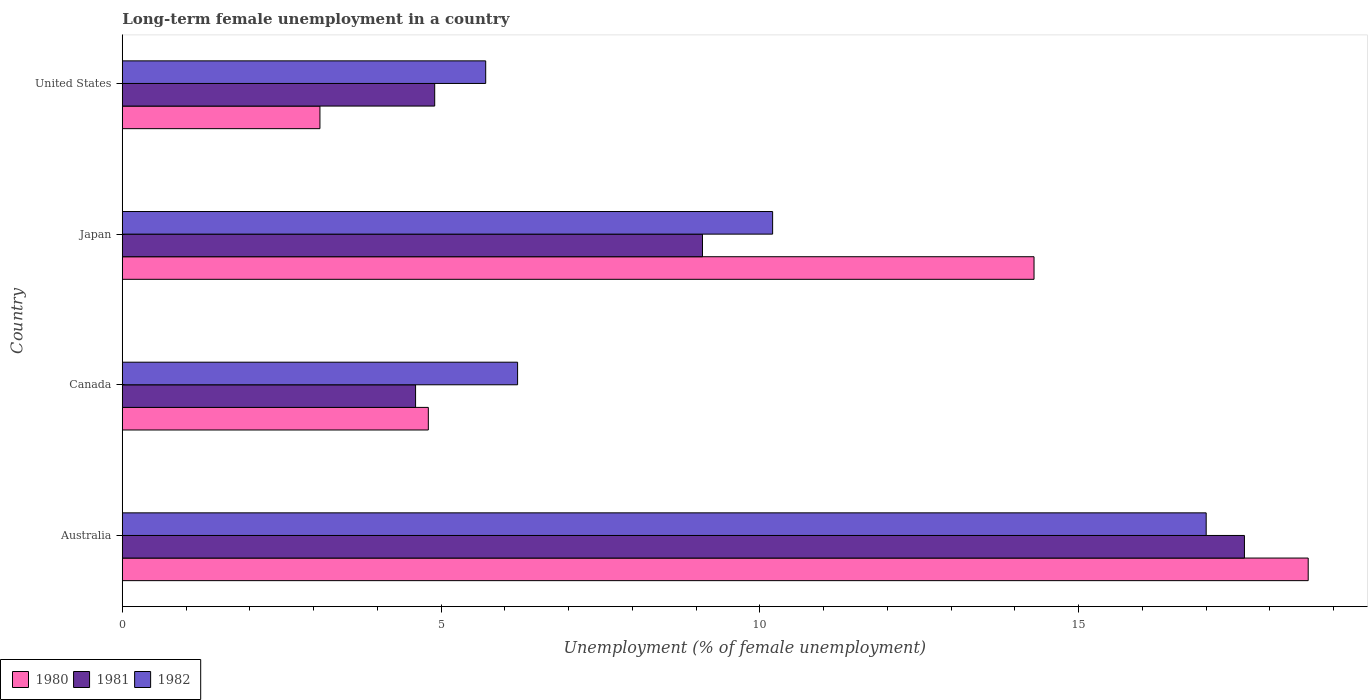How many different coloured bars are there?
Your response must be concise. 3. How many groups of bars are there?
Your answer should be compact. 4. Are the number of bars per tick equal to the number of legend labels?
Offer a terse response. Yes. How many bars are there on the 2nd tick from the top?
Make the answer very short. 3. In how many cases, is the number of bars for a given country not equal to the number of legend labels?
Offer a very short reply. 0. What is the percentage of long-term unemployed female population in 1980 in Japan?
Your answer should be very brief. 14.3. Across all countries, what is the maximum percentage of long-term unemployed female population in 1980?
Offer a terse response. 18.6. Across all countries, what is the minimum percentage of long-term unemployed female population in 1982?
Make the answer very short. 5.7. In which country was the percentage of long-term unemployed female population in 1980 minimum?
Make the answer very short. United States. What is the total percentage of long-term unemployed female population in 1981 in the graph?
Offer a very short reply. 36.2. What is the difference between the percentage of long-term unemployed female population in 1980 in Canada and that in Japan?
Your response must be concise. -9.5. What is the difference between the percentage of long-term unemployed female population in 1980 in Japan and the percentage of long-term unemployed female population in 1981 in Canada?
Provide a short and direct response. 9.7. What is the average percentage of long-term unemployed female population in 1981 per country?
Make the answer very short. 9.05. What is the difference between the percentage of long-term unemployed female population in 1982 and percentage of long-term unemployed female population in 1980 in Japan?
Give a very brief answer. -4.1. In how many countries, is the percentage of long-term unemployed female population in 1981 greater than 4 %?
Your answer should be compact. 4. What is the ratio of the percentage of long-term unemployed female population in 1982 in Australia to that in United States?
Your answer should be very brief. 2.98. Is the difference between the percentage of long-term unemployed female population in 1982 in Australia and United States greater than the difference between the percentage of long-term unemployed female population in 1980 in Australia and United States?
Offer a very short reply. No. What is the difference between the highest and the second highest percentage of long-term unemployed female population in 1982?
Give a very brief answer. 6.8. What is the difference between the highest and the lowest percentage of long-term unemployed female population in 1980?
Provide a short and direct response. 15.5. In how many countries, is the percentage of long-term unemployed female population in 1980 greater than the average percentage of long-term unemployed female population in 1980 taken over all countries?
Your answer should be very brief. 2. Is the sum of the percentage of long-term unemployed female population in 1980 in Australia and United States greater than the maximum percentage of long-term unemployed female population in 1982 across all countries?
Your response must be concise. Yes. What does the 1st bar from the bottom in Japan represents?
Your answer should be compact. 1980. Are all the bars in the graph horizontal?
Offer a very short reply. Yes. What is the difference between two consecutive major ticks on the X-axis?
Keep it short and to the point. 5. Are the values on the major ticks of X-axis written in scientific E-notation?
Your response must be concise. No. Where does the legend appear in the graph?
Keep it short and to the point. Bottom left. How many legend labels are there?
Offer a terse response. 3. What is the title of the graph?
Offer a terse response. Long-term female unemployment in a country. Does "2004" appear as one of the legend labels in the graph?
Offer a terse response. No. What is the label or title of the X-axis?
Give a very brief answer. Unemployment (% of female unemployment). What is the label or title of the Y-axis?
Make the answer very short. Country. What is the Unemployment (% of female unemployment) of 1980 in Australia?
Your answer should be compact. 18.6. What is the Unemployment (% of female unemployment) of 1981 in Australia?
Your answer should be very brief. 17.6. What is the Unemployment (% of female unemployment) in 1980 in Canada?
Keep it short and to the point. 4.8. What is the Unemployment (% of female unemployment) in 1981 in Canada?
Give a very brief answer. 4.6. What is the Unemployment (% of female unemployment) in 1982 in Canada?
Provide a short and direct response. 6.2. What is the Unemployment (% of female unemployment) in 1980 in Japan?
Give a very brief answer. 14.3. What is the Unemployment (% of female unemployment) in 1981 in Japan?
Your answer should be very brief. 9.1. What is the Unemployment (% of female unemployment) of 1982 in Japan?
Your response must be concise. 10.2. What is the Unemployment (% of female unemployment) of 1980 in United States?
Provide a short and direct response. 3.1. What is the Unemployment (% of female unemployment) of 1981 in United States?
Keep it short and to the point. 4.9. What is the Unemployment (% of female unemployment) of 1982 in United States?
Make the answer very short. 5.7. Across all countries, what is the maximum Unemployment (% of female unemployment) of 1980?
Your response must be concise. 18.6. Across all countries, what is the maximum Unemployment (% of female unemployment) in 1981?
Provide a succinct answer. 17.6. Across all countries, what is the minimum Unemployment (% of female unemployment) of 1980?
Give a very brief answer. 3.1. Across all countries, what is the minimum Unemployment (% of female unemployment) of 1981?
Offer a terse response. 4.6. Across all countries, what is the minimum Unemployment (% of female unemployment) in 1982?
Provide a short and direct response. 5.7. What is the total Unemployment (% of female unemployment) in 1980 in the graph?
Offer a very short reply. 40.8. What is the total Unemployment (% of female unemployment) of 1981 in the graph?
Your answer should be very brief. 36.2. What is the total Unemployment (% of female unemployment) of 1982 in the graph?
Provide a succinct answer. 39.1. What is the difference between the Unemployment (% of female unemployment) of 1981 in Australia and that in Canada?
Keep it short and to the point. 13. What is the difference between the Unemployment (% of female unemployment) in 1982 in Australia and that in Canada?
Provide a short and direct response. 10.8. What is the difference between the Unemployment (% of female unemployment) of 1980 in Australia and that in Japan?
Your answer should be very brief. 4.3. What is the difference between the Unemployment (% of female unemployment) in 1981 in Australia and that in Japan?
Make the answer very short. 8.5. What is the difference between the Unemployment (% of female unemployment) of 1982 in Australia and that in Japan?
Your response must be concise. 6.8. What is the difference between the Unemployment (% of female unemployment) in 1980 in Australia and that in United States?
Make the answer very short. 15.5. What is the difference between the Unemployment (% of female unemployment) of 1980 in Canada and that in Japan?
Give a very brief answer. -9.5. What is the difference between the Unemployment (% of female unemployment) in 1982 in Canada and that in United States?
Offer a very short reply. 0.5. What is the difference between the Unemployment (% of female unemployment) of 1980 in Australia and the Unemployment (% of female unemployment) of 1981 in Canada?
Keep it short and to the point. 14. What is the difference between the Unemployment (% of female unemployment) of 1981 in Australia and the Unemployment (% of female unemployment) of 1982 in Canada?
Ensure brevity in your answer.  11.4. What is the difference between the Unemployment (% of female unemployment) of 1981 in Australia and the Unemployment (% of female unemployment) of 1982 in Japan?
Offer a terse response. 7.4. What is the difference between the Unemployment (% of female unemployment) in 1980 in Australia and the Unemployment (% of female unemployment) in 1981 in United States?
Provide a succinct answer. 13.7. What is the difference between the Unemployment (% of female unemployment) of 1980 in Australia and the Unemployment (% of female unemployment) of 1982 in United States?
Keep it short and to the point. 12.9. What is the difference between the Unemployment (% of female unemployment) of 1980 in Canada and the Unemployment (% of female unemployment) of 1981 in United States?
Give a very brief answer. -0.1. What is the difference between the Unemployment (% of female unemployment) of 1980 in Canada and the Unemployment (% of female unemployment) of 1982 in United States?
Make the answer very short. -0.9. What is the average Unemployment (% of female unemployment) in 1980 per country?
Offer a very short reply. 10.2. What is the average Unemployment (% of female unemployment) of 1981 per country?
Provide a succinct answer. 9.05. What is the average Unemployment (% of female unemployment) in 1982 per country?
Your answer should be compact. 9.78. What is the difference between the Unemployment (% of female unemployment) in 1980 and Unemployment (% of female unemployment) in 1982 in Australia?
Provide a short and direct response. 1.6. What is the difference between the Unemployment (% of female unemployment) of 1981 and Unemployment (% of female unemployment) of 1982 in Australia?
Offer a very short reply. 0.6. What is the difference between the Unemployment (% of female unemployment) of 1981 and Unemployment (% of female unemployment) of 1982 in Canada?
Ensure brevity in your answer.  -1.6. What is the difference between the Unemployment (% of female unemployment) in 1981 and Unemployment (% of female unemployment) in 1982 in Japan?
Ensure brevity in your answer.  -1.1. What is the difference between the Unemployment (% of female unemployment) in 1980 and Unemployment (% of female unemployment) in 1981 in United States?
Keep it short and to the point. -1.8. What is the difference between the Unemployment (% of female unemployment) of 1981 and Unemployment (% of female unemployment) of 1982 in United States?
Give a very brief answer. -0.8. What is the ratio of the Unemployment (% of female unemployment) in 1980 in Australia to that in Canada?
Your response must be concise. 3.88. What is the ratio of the Unemployment (% of female unemployment) in 1981 in Australia to that in Canada?
Offer a very short reply. 3.83. What is the ratio of the Unemployment (% of female unemployment) in 1982 in Australia to that in Canada?
Provide a succinct answer. 2.74. What is the ratio of the Unemployment (% of female unemployment) of 1980 in Australia to that in Japan?
Your answer should be compact. 1.3. What is the ratio of the Unemployment (% of female unemployment) of 1981 in Australia to that in Japan?
Keep it short and to the point. 1.93. What is the ratio of the Unemployment (% of female unemployment) in 1982 in Australia to that in Japan?
Your answer should be compact. 1.67. What is the ratio of the Unemployment (% of female unemployment) in 1981 in Australia to that in United States?
Your answer should be compact. 3.59. What is the ratio of the Unemployment (% of female unemployment) in 1982 in Australia to that in United States?
Provide a short and direct response. 2.98. What is the ratio of the Unemployment (% of female unemployment) in 1980 in Canada to that in Japan?
Offer a terse response. 0.34. What is the ratio of the Unemployment (% of female unemployment) in 1981 in Canada to that in Japan?
Keep it short and to the point. 0.51. What is the ratio of the Unemployment (% of female unemployment) in 1982 in Canada to that in Japan?
Ensure brevity in your answer.  0.61. What is the ratio of the Unemployment (% of female unemployment) in 1980 in Canada to that in United States?
Offer a very short reply. 1.55. What is the ratio of the Unemployment (% of female unemployment) of 1981 in Canada to that in United States?
Provide a short and direct response. 0.94. What is the ratio of the Unemployment (% of female unemployment) in 1982 in Canada to that in United States?
Offer a very short reply. 1.09. What is the ratio of the Unemployment (% of female unemployment) in 1980 in Japan to that in United States?
Your answer should be very brief. 4.61. What is the ratio of the Unemployment (% of female unemployment) of 1981 in Japan to that in United States?
Make the answer very short. 1.86. What is the ratio of the Unemployment (% of female unemployment) of 1982 in Japan to that in United States?
Provide a short and direct response. 1.79. What is the difference between the highest and the second highest Unemployment (% of female unemployment) of 1980?
Offer a very short reply. 4.3. What is the difference between the highest and the second highest Unemployment (% of female unemployment) in 1982?
Offer a terse response. 6.8. What is the difference between the highest and the lowest Unemployment (% of female unemployment) of 1980?
Offer a terse response. 15.5. 